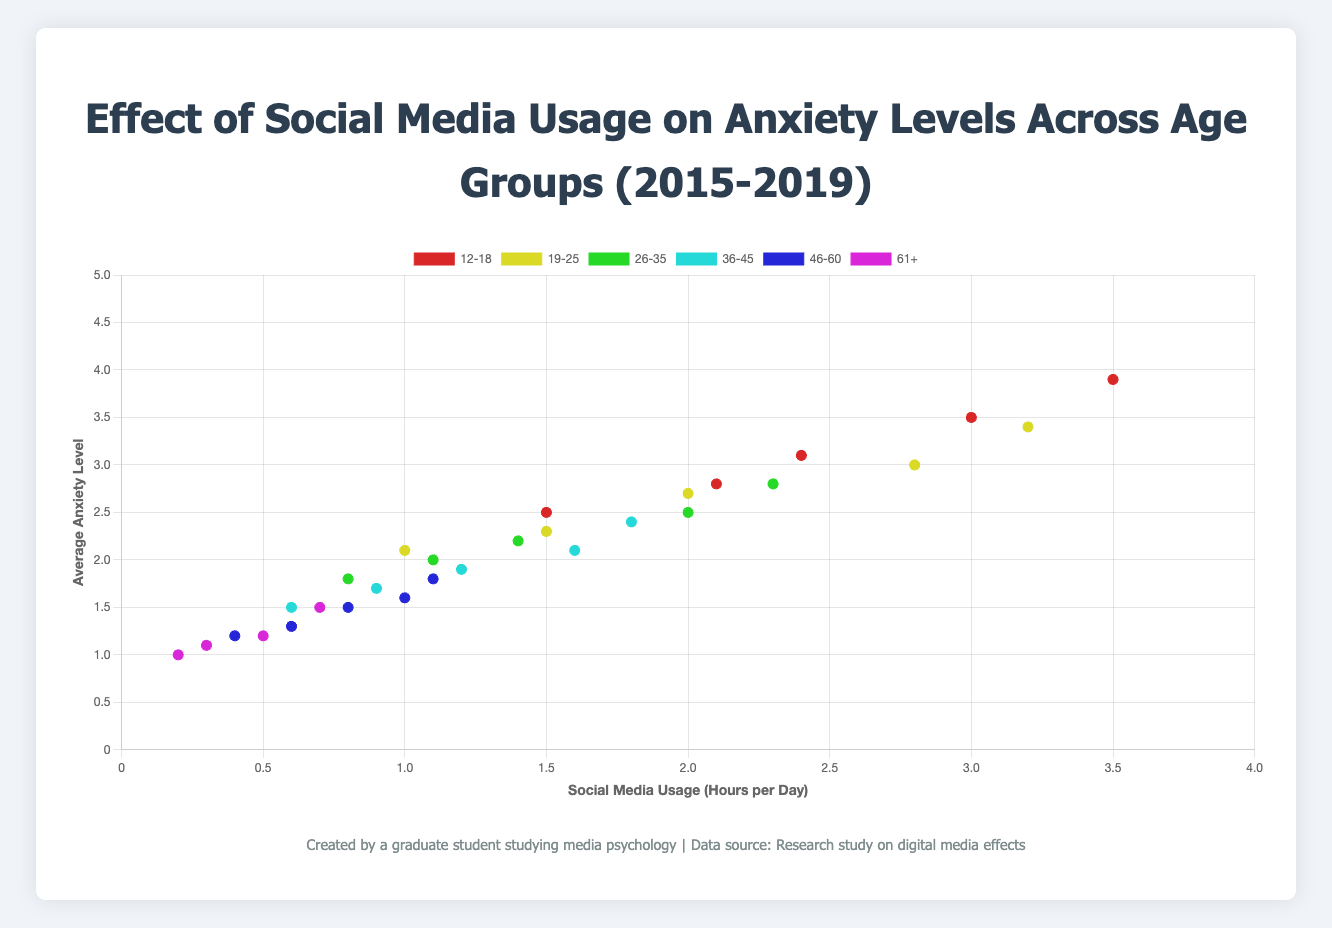What's the trend in social media usage for the 12-18 age group over the years 2015 to 2019? From the figure, we can trace the points corresponding to the 12-18 age group. In 2015, social media usage is 1.5 hours per day, gradually increasing each year up to 3.5 hours per day in 2019. Therefore, the trend shows a steady increase in social media usage for the 12-18 age group over the years.
Answer: Steady increase Which age group had the highest average anxiety level in 2019, and what was that level? We refer to the points for all age groups in 2019. By comparing the Y-values, we see the 12-18 age group has the highest average anxiety level at 3.9.
Answer: 12-18, 3.9 Compare the social media usage between the 26-35 and 61+ age groups in 2017. Which group used social media more, and by how much? From the figure, the 26-35 age group in 2017 used social media for 1.4 hours per day, while the 61+ age group used it for 0.5 hours per day. The 26-35 age group used social media 0.9 hours more than the 61+ age group.
Answer: 26-35, 0.9 hours How does the change in anxiety level from 2017 to 2019 compare between the 19-25 and 36-45 age groups? For the 19-25 age group, the anxiety level changed from 2.7 to 3.4, an increase of 0.7. For the 36-45 age group, the anxiety level changed from 1.9 to 2.4, an increase of 0.5. Therefore, the 19-25 age group saw a greater increase in anxiety than the 36-45 age group.
Answer: 19-25: 0.7, 36-45: 0.5 What visual patterns indicate that social media usage correlates with anxiety levels across age groups? The visual pattern on the scatter plot shows that as points move to the right (indicating higher social media usage per day), they also tend to move upward (indicating higher average anxiety levels). This pattern holds across different age groups, suggesting a positive correlation between social media usage and anxiety levels.
Answer: Positive correlation Which age group had the smallest increase in social media usage from 2016 to 2019, and what was the increase? By examining the data points for each age group from 2016 to 2019, we see the 61+ age group had an increase from 0.3 to 0.7 hours per day, a change of 0.4 hours. This is the smallest increase compared to other age groups.
Answer: 61+, 0.4 hours What is the difference in anxiety levels between the 46-60 age group and the 12-18 age group in 2017? From the figure, the anxiety level for the 46-60 age group in 2017 is 1.5, and for the 12-18 age group, it is 3.1. The difference in anxiety levels is 3.1 - 1.5 = 1.6.
Answer: 1.6 Identify the age group showing the least variability in social media usage from 2015 to 2019 and describe the pattern. The 61+ age group shows the least variability in social media usage, ranging only from 0.2 to 0.7 hours per day. The pattern is a gradual, consistent increase.
Answer: 61+, least variability In 2018, which age group spent more than twice the hours on social media compared to the 61+ age group, and what were the usage hours? In 2018, the 61+ age group used social media for 0.6 hours per day. The 12-18, 19-25, 26-35, 36-45 age groups all used more than twice the hours. Specifically, the 12-18 age group used 3.0 hours.
Answer: 12-18, 3.0 hours Calculate the average increase in anxiety levels from 2015 to 2019 for the 26-35 age group. The anxiety levels for the 26-35 age group from 2015 to 2019 are 1.8, 2.0, 2.2, 2.5, and 2.8, respectively. The increase is calculated as (2.0-1.8) + (2.2-2.0) + (2.5-2.2) + (2.8-2.5) = 0.2 + 0.2 + 0.3 + 0.3 = 1.0. So, the average increase is 1.0/4 = 0.25.
Answer: 0.25 